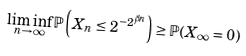<formula> <loc_0><loc_0><loc_500><loc_500>\liminf _ { n \to \infty } \mathbb { P } \left ( X _ { n } \leq 2 ^ { - 2 ^ { \beta n } } \right ) \geq \mathbb { P } ( X _ { \infty } = 0 )</formula> 